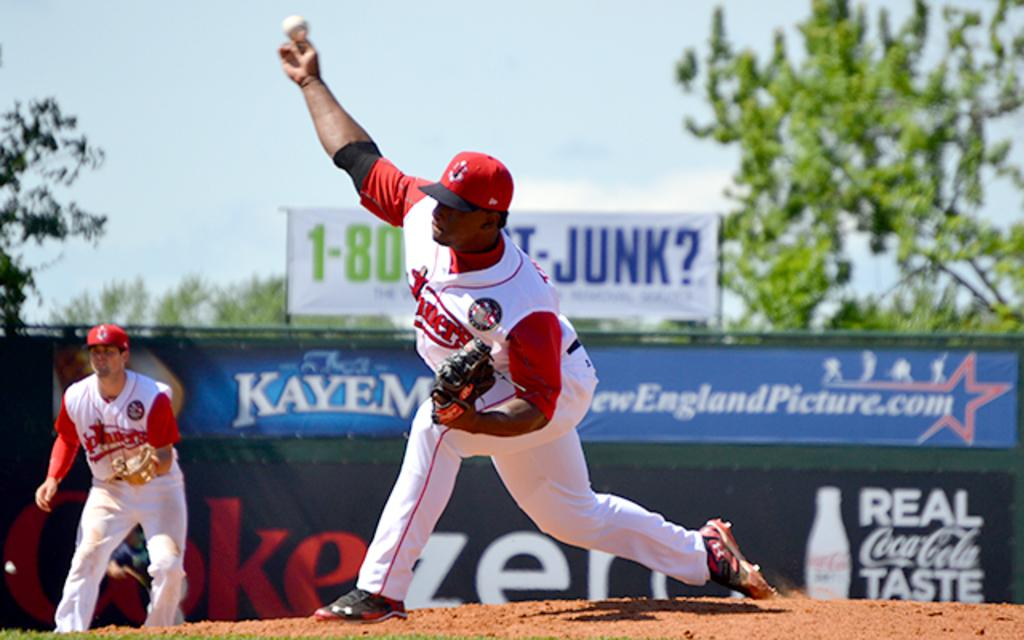<image>
Summarize the visual content of the image. A baseball player throws a baseball while another player looks on with a Coca Cola and CokeZero sign hang in the background. 